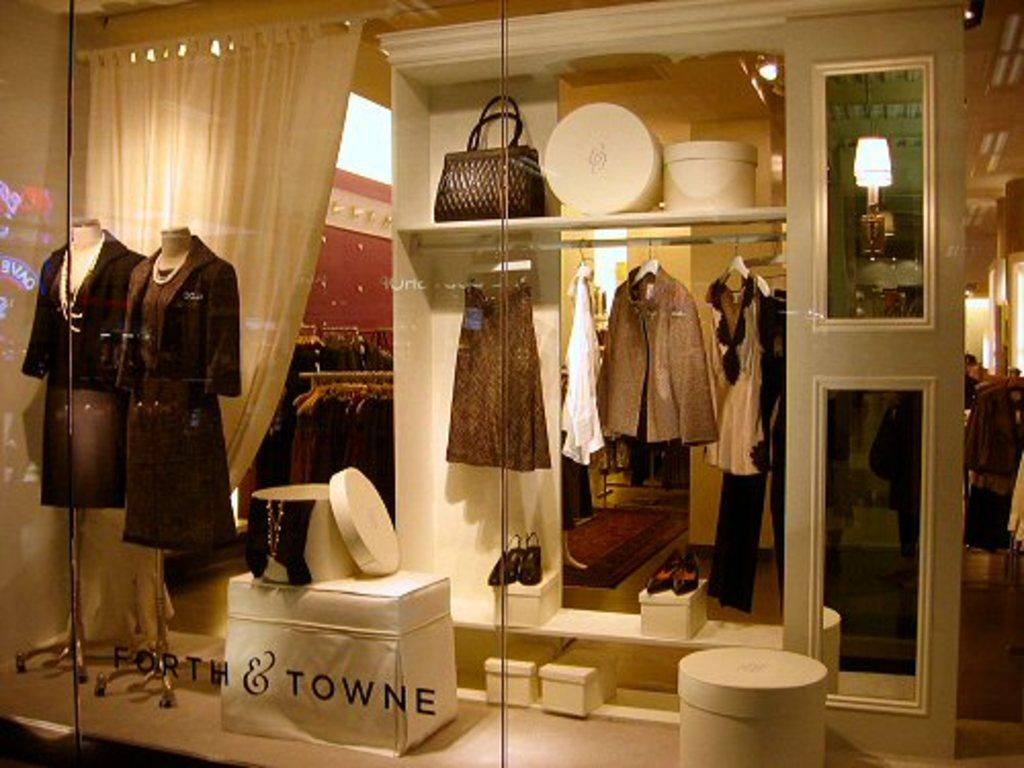<image>
Describe the image concisely. Ladies clothing shop window featuring dresses and the name Forth & Towne 